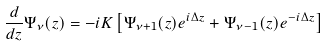<formula> <loc_0><loc_0><loc_500><loc_500>\frac { d } { d z } \Psi _ { \nu } ( z ) = - i K \left [ \Psi _ { \nu + 1 } ( z ) e ^ { i \Delta z } + \Psi _ { \nu - 1 } ( z ) e ^ { - i \Delta z } \right ]</formula> 